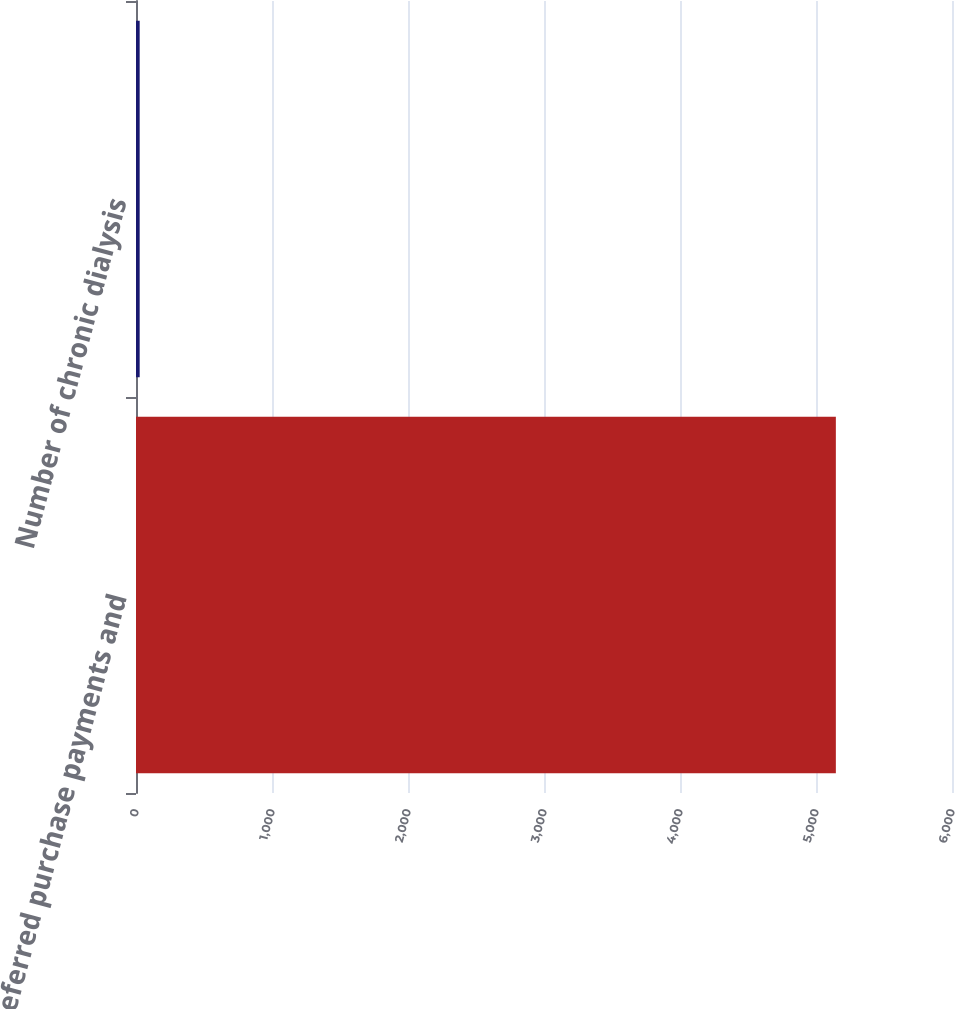Convert chart to OTSL. <chart><loc_0><loc_0><loc_500><loc_500><bar_chart><fcel>Deferred purchase payments and<fcel>Number of chronic dialysis<nl><fcel>5146<fcel>27<nl></chart> 